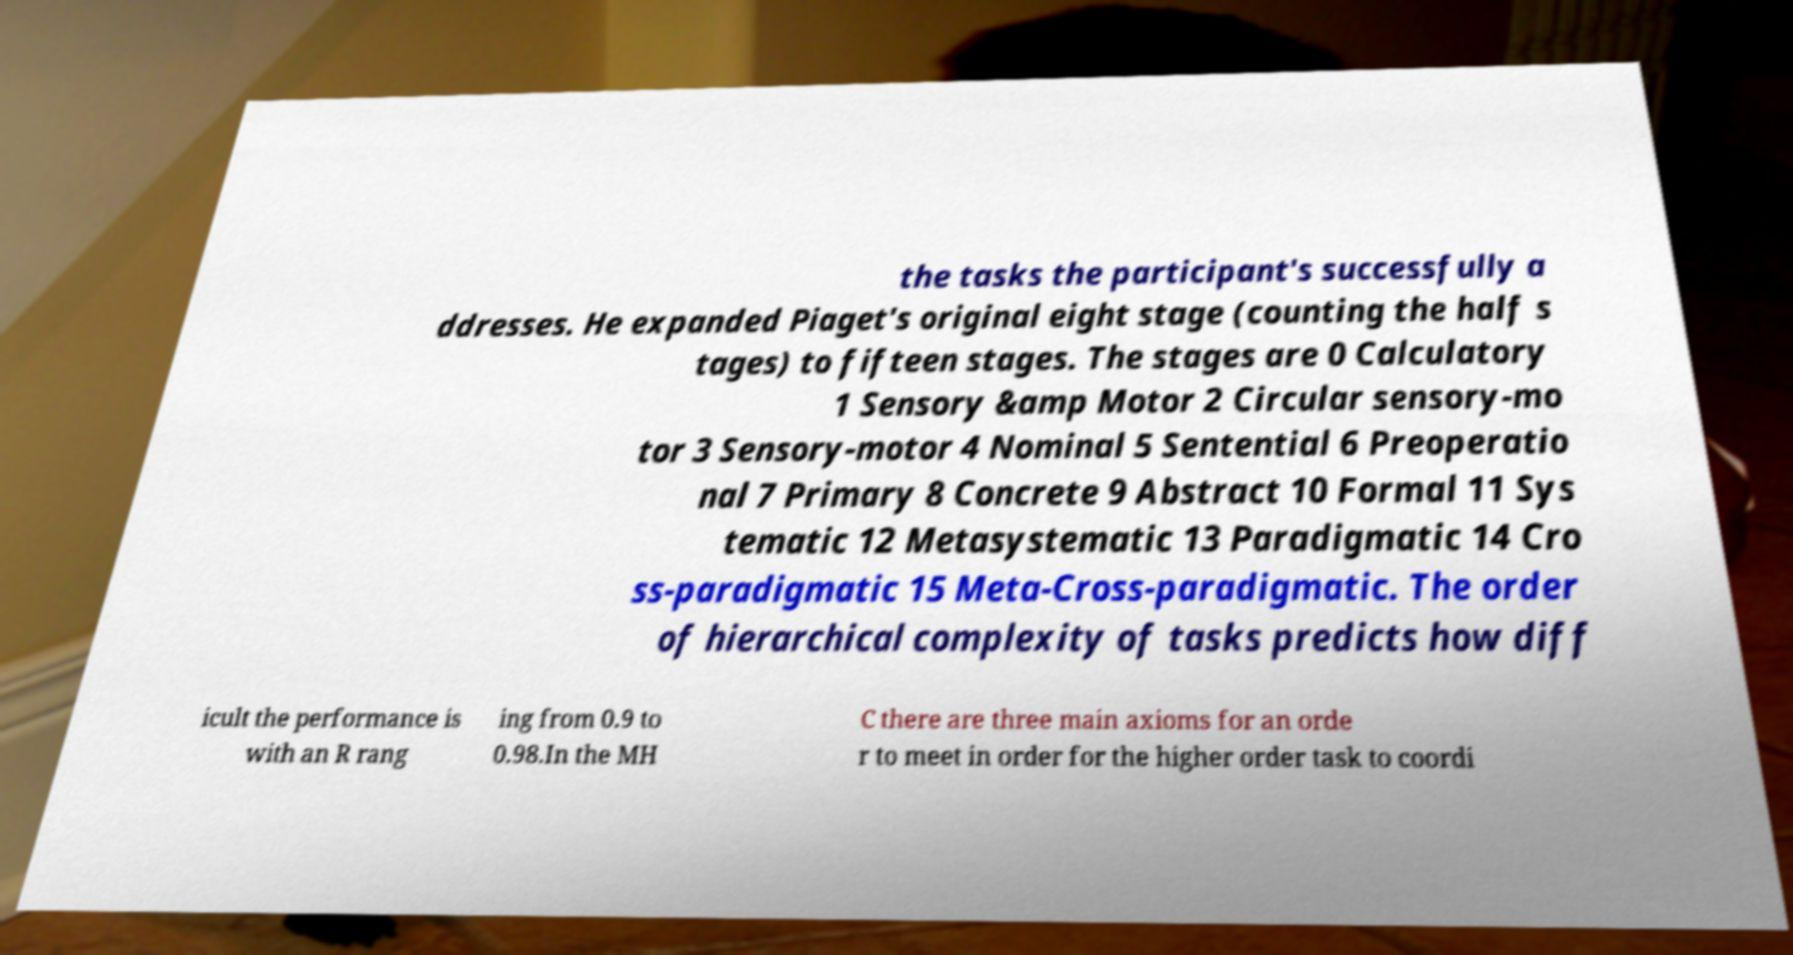I need the written content from this picture converted into text. Can you do that? the tasks the participant's successfully a ddresses. He expanded Piaget's original eight stage (counting the half s tages) to fifteen stages. The stages are 0 Calculatory 1 Sensory &amp Motor 2 Circular sensory-mo tor 3 Sensory-motor 4 Nominal 5 Sentential 6 Preoperatio nal 7 Primary 8 Concrete 9 Abstract 10 Formal 11 Sys tematic 12 Metasystematic 13 Paradigmatic 14 Cro ss-paradigmatic 15 Meta-Cross-paradigmatic. The order of hierarchical complexity of tasks predicts how diff icult the performance is with an R rang ing from 0.9 to 0.98.In the MH C there are three main axioms for an orde r to meet in order for the higher order task to coordi 